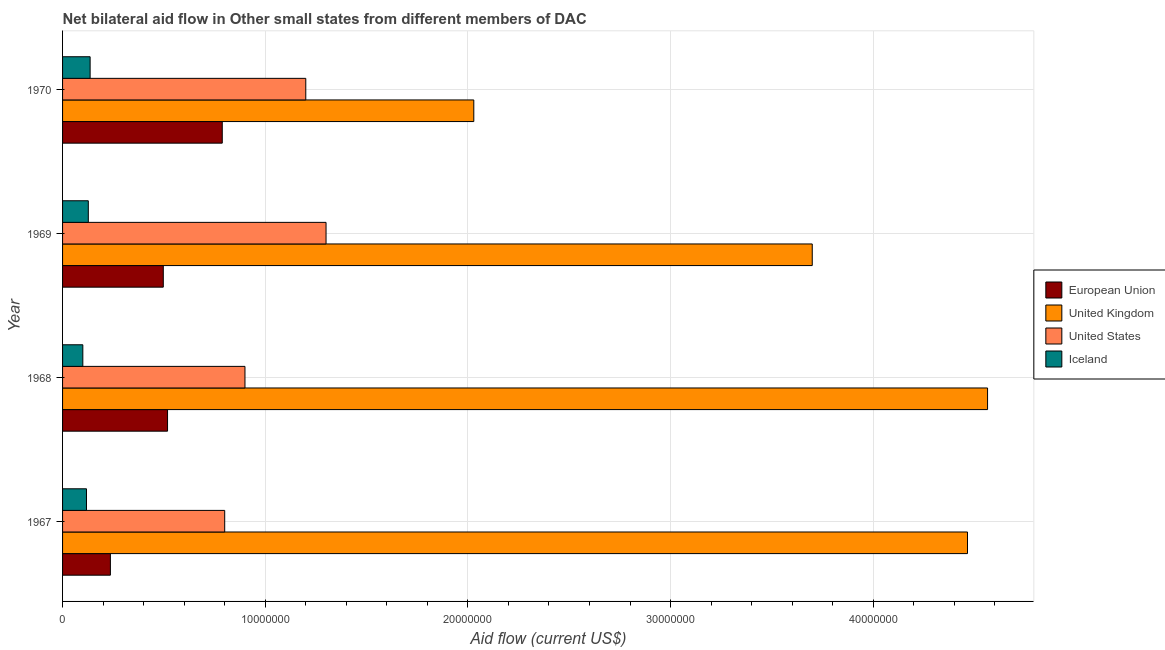Are the number of bars per tick equal to the number of legend labels?
Keep it short and to the point. Yes. How many bars are there on the 1st tick from the top?
Your response must be concise. 4. How many bars are there on the 1st tick from the bottom?
Make the answer very short. 4. What is the label of the 1st group of bars from the top?
Keep it short and to the point. 1970. What is the amount of aid given by uk in 1967?
Make the answer very short. 4.46e+07. Across all years, what is the maximum amount of aid given by eu?
Make the answer very short. 7.88e+06. Across all years, what is the minimum amount of aid given by us?
Your answer should be very brief. 8.00e+06. In which year was the amount of aid given by uk maximum?
Make the answer very short. 1968. In which year was the amount of aid given by uk minimum?
Your response must be concise. 1970. What is the total amount of aid given by us in the graph?
Provide a short and direct response. 4.20e+07. What is the difference between the amount of aid given by us in 1967 and that in 1970?
Provide a succinct answer. -4.00e+06. What is the difference between the amount of aid given by us in 1970 and the amount of aid given by eu in 1967?
Keep it short and to the point. 9.64e+06. What is the average amount of aid given by iceland per year?
Offer a very short reply. 1.20e+06. In the year 1970, what is the difference between the amount of aid given by us and amount of aid given by eu?
Make the answer very short. 4.12e+06. What is the ratio of the amount of aid given by eu in 1968 to that in 1970?
Ensure brevity in your answer.  0.66. Is the difference between the amount of aid given by eu in 1968 and 1969 greater than the difference between the amount of aid given by uk in 1968 and 1969?
Offer a very short reply. No. What is the difference between the highest and the lowest amount of aid given by eu?
Give a very brief answer. 5.52e+06. Is it the case that in every year, the sum of the amount of aid given by iceland and amount of aid given by us is greater than the sum of amount of aid given by eu and amount of aid given by uk?
Provide a short and direct response. No. What does the 3rd bar from the top in 1967 represents?
Make the answer very short. United Kingdom. What does the 2nd bar from the bottom in 1970 represents?
Provide a succinct answer. United Kingdom. Is it the case that in every year, the sum of the amount of aid given by eu and amount of aid given by uk is greater than the amount of aid given by us?
Your answer should be very brief. Yes. Does the graph contain grids?
Keep it short and to the point. Yes. How many legend labels are there?
Keep it short and to the point. 4. How are the legend labels stacked?
Make the answer very short. Vertical. What is the title of the graph?
Your response must be concise. Net bilateral aid flow in Other small states from different members of DAC. Does "HFC gas" appear as one of the legend labels in the graph?
Provide a succinct answer. No. What is the label or title of the X-axis?
Make the answer very short. Aid flow (current US$). What is the label or title of the Y-axis?
Make the answer very short. Year. What is the Aid flow (current US$) of European Union in 1967?
Make the answer very short. 2.36e+06. What is the Aid flow (current US$) in United Kingdom in 1967?
Give a very brief answer. 4.46e+07. What is the Aid flow (current US$) in Iceland in 1967?
Your answer should be compact. 1.18e+06. What is the Aid flow (current US$) in European Union in 1968?
Provide a succinct answer. 5.18e+06. What is the Aid flow (current US$) in United Kingdom in 1968?
Ensure brevity in your answer.  4.56e+07. What is the Aid flow (current US$) of United States in 1968?
Give a very brief answer. 9.00e+06. What is the Aid flow (current US$) in European Union in 1969?
Your answer should be compact. 4.97e+06. What is the Aid flow (current US$) in United Kingdom in 1969?
Keep it short and to the point. 3.70e+07. What is the Aid flow (current US$) of United States in 1969?
Give a very brief answer. 1.30e+07. What is the Aid flow (current US$) of Iceland in 1969?
Make the answer very short. 1.27e+06. What is the Aid flow (current US$) in European Union in 1970?
Your answer should be compact. 7.88e+06. What is the Aid flow (current US$) of United Kingdom in 1970?
Provide a succinct answer. 2.03e+07. What is the Aid flow (current US$) of Iceland in 1970?
Your answer should be compact. 1.36e+06. Across all years, what is the maximum Aid flow (current US$) in European Union?
Ensure brevity in your answer.  7.88e+06. Across all years, what is the maximum Aid flow (current US$) in United Kingdom?
Your response must be concise. 4.56e+07. Across all years, what is the maximum Aid flow (current US$) in United States?
Your response must be concise. 1.30e+07. Across all years, what is the maximum Aid flow (current US$) in Iceland?
Offer a very short reply. 1.36e+06. Across all years, what is the minimum Aid flow (current US$) of European Union?
Offer a terse response. 2.36e+06. Across all years, what is the minimum Aid flow (current US$) in United Kingdom?
Your answer should be compact. 2.03e+07. Across all years, what is the minimum Aid flow (current US$) of United States?
Keep it short and to the point. 8.00e+06. What is the total Aid flow (current US$) of European Union in the graph?
Provide a succinct answer. 2.04e+07. What is the total Aid flow (current US$) of United Kingdom in the graph?
Offer a terse response. 1.48e+08. What is the total Aid flow (current US$) of United States in the graph?
Keep it short and to the point. 4.20e+07. What is the total Aid flow (current US$) of Iceland in the graph?
Your response must be concise. 4.81e+06. What is the difference between the Aid flow (current US$) of European Union in 1967 and that in 1968?
Your response must be concise. -2.82e+06. What is the difference between the Aid flow (current US$) in United Kingdom in 1967 and that in 1968?
Make the answer very short. -9.90e+05. What is the difference between the Aid flow (current US$) of United States in 1967 and that in 1968?
Give a very brief answer. -1.00e+06. What is the difference between the Aid flow (current US$) in European Union in 1967 and that in 1969?
Ensure brevity in your answer.  -2.61e+06. What is the difference between the Aid flow (current US$) in United Kingdom in 1967 and that in 1969?
Provide a succinct answer. 7.66e+06. What is the difference between the Aid flow (current US$) of United States in 1967 and that in 1969?
Your response must be concise. -5.00e+06. What is the difference between the Aid flow (current US$) in Iceland in 1967 and that in 1969?
Provide a succinct answer. -9.00e+04. What is the difference between the Aid flow (current US$) in European Union in 1967 and that in 1970?
Make the answer very short. -5.52e+06. What is the difference between the Aid flow (current US$) of United Kingdom in 1967 and that in 1970?
Offer a very short reply. 2.44e+07. What is the difference between the Aid flow (current US$) in European Union in 1968 and that in 1969?
Offer a very short reply. 2.10e+05. What is the difference between the Aid flow (current US$) in United Kingdom in 1968 and that in 1969?
Provide a short and direct response. 8.65e+06. What is the difference between the Aid flow (current US$) in United States in 1968 and that in 1969?
Keep it short and to the point. -4.00e+06. What is the difference between the Aid flow (current US$) of Iceland in 1968 and that in 1969?
Provide a succinct answer. -2.70e+05. What is the difference between the Aid flow (current US$) of European Union in 1968 and that in 1970?
Offer a terse response. -2.70e+06. What is the difference between the Aid flow (current US$) of United Kingdom in 1968 and that in 1970?
Provide a short and direct response. 2.54e+07. What is the difference between the Aid flow (current US$) of United States in 1968 and that in 1970?
Your answer should be very brief. -3.00e+06. What is the difference between the Aid flow (current US$) of Iceland in 1968 and that in 1970?
Keep it short and to the point. -3.60e+05. What is the difference between the Aid flow (current US$) in European Union in 1969 and that in 1970?
Offer a very short reply. -2.91e+06. What is the difference between the Aid flow (current US$) of United Kingdom in 1969 and that in 1970?
Offer a terse response. 1.67e+07. What is the difference between the Aid flow (current US$) in Iceland in 1969 and that in 1970?
Offer a terse response. -9.00e+04. What is the difference between the Aid flow (current US$) of European Union in 1967 and the Aid flow (current US$) of United Kingdom in 1968?
Ensure brevity in your answer.  -4.33e+07. What is the difference between the Aid flow (current US$) in European Union in 1967 and the Aid flow (current US$) in United States in 1968?
Ensure brevity in your answer.  -6.64e+06. What is the difference between the Aid flow (current US$) in European Union in 1967 and the Aid flow (current US$) in Iceland in 1968?
Offer a terse response. 1.36e+06. What is the difference between the Aid flow (current US$) in United Kingdom in 1967 and the Aid flow (current US$) in United States in 1968?
Offer a very short reply. 3.56e+07. What is the difference between the Aid flow (current US$) of United Kingdom in 1967 and the Aid flow (current US$) of Iceland in 1968?
Keep it short and to the point. 4.36e+07. What is the difference between the Aid flow (current US$) in European Union in 1967 and the Aid flow (current US$) in United Kingdom in 1969?
Your answer should be very brief. -3.46e+07. What is the difference between the Aid flow (current US$) in European Union in 1967 and the Aid flow (current US$) in United States in 1969?
Offer a very short reply. -1.06e+07. What is the difference between the Aid flow (current US$) in European Union in 1967 and the Aid flow (current US$) in Iceland in 1969?
Make the answer very short. 1.09e+06. What is the difference between the Aid flow (current US$) of United Kingdom in 1967 and the Aid flow (current US$) of United States in 1969?
Provide a short and direct response. 3.16e+07. What is the difference between the Aid flow (current US$) in United Kingdom in 1967 and the Aid flow (current US$) in Iceland in 1969?
Make the answer very short. 4.34e+07. What is the difference between the Aid flow (current US$) of United States in 1967 and the Aid flow (current US$) of Iceland in 1969?
Make the answer very short. 6.73e+06. What is the difference between the Aid flow (current US$) of European Union in 1967 and the Aid flow (current US$) of United Kingdom in 1970?
Your response must be concise. -1.79e+07. What is the difference between the Aid flow (current US$) in European Union in 1967 and the Aid flow (current US$) in United States in 1970?
Provide a short and direct response. -9.64e+06. What is the difference between the Aid flow (current US$) of United Kingdom in 1967 and the Aid flow (current US$) of United States in 1970?
Your answer should be very brief. 3.26e+07. What is the difference between the Aid flow (current US$) of United Kingdom in 1967 and the Aid flow (current US$) of Iceland in 1970?
Provide a short and direct response. 4.33e+07. What is the difference between the Aid flow (current US$) of United States in 1967 and the Aid flow (current US$) of Iceland in 1970?
Keep it short and to the point. 6.64e+06. What is the difference between the Aid flow (current US$) of European Union in 1968 and the Aid flow (current US$) of United Kingdom in 1969?
Provide a succinct answer. -3.18e+07. What is the difference between the Aid flow (current US$) in European Union in 1968 and the Aid flow (current US$) in United States in 1969?
Provide a short and direct response. -7.82e+06. What is the difference between the Aid flow (current US$) of European Union in 1968 and the Aid flow (current US$) of Iceland in 1969?
Make the answer very short. 3.91e+06. What is the difference between the Aid flow (current US$) in United Kingdom in 1968 and the Aid flow (current US$) in United States in 1969?
Give a very brief answer. 3.26e+07. What is the difference between the Aid flow (current US$) in United Kingdom in 1968 and the Aid flow (current US$) in Iceland in 1969?
Your answer should be very brief. 4.44e+07. What is the difference between the Aid flow (current US$) of United States in 1968 and the Aid flow (current US$) of Iceland in 1969?
Offer a terse response. 7.73e+06. What is the difference between the Aid flow (current US$) in European Union in 1968 and the Aid flow (current US$) in United Kingdom in 1970?
Your response must be concise. -1.51e+07. What is the difference between the Aid flow (current US$) of European Union in 1968 and the Aid flow (current US$) of United States in 1970?
Your answer should be very brief. -6.82e+06. What is the difference between the Aid flow (current US$) of European Union in 1968 and the Aid flow (current US$) of Iceland in 1970?
Offer a very short reply. 3.82e+06. What is the difference between the Aid flow (current US$) of United Kingdom in 1968 and the Aid flow (current US$) of United States in 1970?
Provide a succinct answer. 3.36e+07. What is the difference between the Aid flow (current US$) of United Kingdom in 1968 and the Aid flow (current US$) of Iceland in 1970?
Your response must be concise. 4.43e+07. What is the difference between the Aid flow (current US$) of United States in 1968 and the Aid flow (current US$) of Iceland in 1970?
Make the answer very short. 7.64e+06. What is the difference between the Aid flow (current US$) in European Union in 1969 and the Aid flow (current US$) in United Kingdom in 1970?
Ensure brevity in your answer.  -1.53e+07. What is the difference between the Aid flow (current US$) of European Union in 1969 and the Aid flow (current US$) of United States in 1970?
Provide a succinct answer. -7.03e+06. What is the difference between the Aid flow (current US$) in European Union in 1969 and the Aid flow (current US$) in Iceland in 1970?
Ensure brevity in your answer.  3.61e+06. What is the difference between the Aid flow (current US$) in United Kingdom in 1969 and the Aid flow (current US$) in United States in 1970?
Offer a terse response. 2.50e+07. What is the difference between the Aid flow (current US$) of United Kingdom in 1969 and the Aid flow (current US$) of Iceland in 1970?
Your answer should be very brief. 3.56e+07. What is the difference between the Aid flow (current US$) in United States in 1969 and the Aid flow (current US$) in Iceland in 1970?
Your response must be concise. 1.16e+07. What is the average Aid flow (current US$) of European Union per year?
Keep it short and to the point. 5.10e+06. What is the average Aid flow (current US$) of United Kingdom per year?
Your answer should be compact. 3.69e+07. What is the average Aid flow (current US$) in United States per year?
Your answer should be compact. 1.05e+07. What is the average Aid flow (current US$) of Iceland per year?
Your answer should be very brief. 1.20e+06. In the year 1967, what is the difference between the Aid flow (current US$) of European Union and Aid flow (current US$) of United Kingdom?
Your answer should be very brief. -4.23e+07. In the year 1967, what is the difference between the Aid flow (current US$) of European Union and Aid flow (current US$) of United States?
Your response must be concise. -5.64e+06. In the year 1967, what is the difference between the Aid flow (current US$) in European Union and Aid flow (current US$) in Iceland?
Ensure brevity in your answer.  1.18e+06. In the year 1967, what is the difference between the Aid flow (current US$) of United Kingdom and Aid flow (current US$) of United States?
Your answer should be compact. 3.66e+07. In the year 1967, what is the difference between the Aid flow (current US$) in United Kingdom and Aid flow (current US$) in Iceland?
Provide a succinct answer. 4.35e+07. In the year 1967, what is the difference between the Aid flow (current US$) in United States and Aid flow (current US$) in Iceland?
Provide a succinct answer. 6.82e+06. In the year 1968, what is the difference between the Aid flow (current US$) in European Union and Aid flow (current US$) in United Kingdom?
Your response must be concise. -4.05e+07. In the year 1968, what is the difference between the Aid flow (current US$) in European Union and Aid flow (current US$) in United States?
Give a very brief answer. -3.82e+06. In the year 1968, what is the difference between the Aid flow (current US$) of European Union and Aid flow (current US$) of Iceland?
Ensure brevity in your answer.  4.18e+06. In the year 1968, what is the difference between the Aid flow (current US$) of United Kingdom and Aid flow (current US$) of United States?
Provide a short and direct response. 3.66e+07. In the year 1968, what is the difference between the Aid flow (current US$) of United Kingdom and Aid flow (current US$) of Iceland?
Ensure brevity in your answer.  4.46e+07. In the year 1968, what is the difference between the Aid flow (current US$) in United States and Aid flow (current US$) in Iceland?
Your response must be concise. 8.00e+06. In the year 1969, what is the difference between the Aid flow (current US$) of European Union and Aid flow (current US$) of United Kingdom?
Keep it short and to the point. -3.20e+07. In the year 1969, what is the difference between the Aid flow (current US$) of European Union and Aid flow (current US$) of United States?
Offer a terse response. -8.03e+06. In the year 1969, what is the difference between the Aid flow (current US$) of European Union and Aid flow (current US$) of Iceland?
Your answer should be very brief. 3.70e+06. In the year 1969, what is the difference between the Aid flow (current US$) of United Kingdom and Aid flow (current US$) of United States?
Ensure brevity in your answer.  2.40e+07. In the year 1969, what is the difference between the Aid flow (current US$) in United Kingdom and Aid flow (current US$) in Iceland?
Offer a terse response. 3.57e+07. In the year 1969, what is the difference between the Aid flow (current US$) of United States and Aid flow (current US$) of Iceland?
Give a very brief answer. 1.17e+07. In the year 1970, what is the difference between the Aid flow (current US$) in European Union and Aid flow (current US$) in United Kingdom?
Your response must be concise. -1.24e+07. In the year 1970, what is the difference between the Aid flow (current US$) of European Union and Aid flow (current US$) of United States?
Make the answer very short. -4.12e+06. In the year 1970, what is the difference between the Aid flow (current US$) of European Union and Aid flow (current US$) of Iceland?
Your answer should be very brief. 6.52e+06. In the year 1970, what is the difference between the Aid flow (current US$) in United Kingdom and Aid flow (current US$) in United States?
Your answer should be compact. 8.29e+06. In the year 1970, what is the difference between the Aid flow (current US$) of United Kingdom and Aid flow (current US$) of Iceland?
Your answer should be very brief. 1.89e+07. In the year 1970, what is the difference between the Aid flow (current US$) of United States and Aid flow (current US$) of Iceland?
Give a very brief answer. 1.06e+07. What is the ratio of the Aid flow (current US$) of European Union in 1967 to that in 1968?
Ensure brevity in your answer.  0.46. What is the ratio of the Aid flow (current US$) in United Kingdom in 1967 to that in 1968?
Give a very brief answer. 0.98. What is the ratio of the Aid flow (current US$) of Iceland in 1967 to that in 1968?
Keep it short and to the point. 1.18. What is the ratio of the Aid flow (current US$) of European Union in 1967 to that in 1969?
Offer a terse response. 0.47. What is the ratio of the Aid flow (current US$) in United Kingdom in 1967 to that in 1969?
Keep it short and to the point. 1.21. What is the ratio of the Aid flow (current US$) in United States in 1967 to that in 1969?
Keep it short and to the point. 0.62. What is the ratio of the Aid flow (current US$) in Iceland in 1967 to that in 1969?
Provide a succinct answer. 0.93. What is the ratio of the Aid flow (current US$) in European Union in 1967 to that in 1970?
Your answer should be very brief. 0.3. What is the ratio of the Aid flow (current US$) of United Kingdom in 1967 to that in 1970?
Your answer should be very brief. 2.2. What is the ratio of the Aid flow (current US$) in United States in 1967 to that in 1970?
Provide a succinct answer. 0.67. What is the ratio of the Aid flow (current US$) in Iceland in 1967 to that in 1970?
Offer a terse response. 0.87. What is the ratio of the Aid flow (current US$) in European Union in 1968 to that in 1969?
Your answer should be very brief. 1.04. What is the ratio of the Aid flow (current US$) of United Kingdom in 1968 to that in 1969?
Offer a terse response. 1.23. What is the ratio of the Aid flow (current US$) of United States in 1968 to that in 1969?
Offer a terse response. 0.69. What is the ratio of the Aid flow (current US$) in Iceland in 1968 to that in 1969?
Your answer should be compact. 0.79. What is the ratio of the Aid flow (current US$) in European Union in 1968 to that in 1970?
Your answer should be very brief. 0.66. What is the ratio of the Aid flow (current US$) of United Kingdom in 1968 to that in 1970?
Keep it short and to the point. 2.25. What is the ratio of the Aid flow (current US$) in Iceland in 1968 to that in 1970?
Make the answer very short. 0.74. What is the ratio of the Aid flow (current US$) of European Union in 1969 to that in 1970?
Make the answer very short. 0.63. What is the ratio of the Aid flow (current US$) in United Kingdom in 1969 to that in 1970?
Offer a terse response. 1.82. What is the ratio of the Aid flow (current US$) in Iceland in 1969 to that in 1970?
Keep it short and to the point. 0.93. What is the difference between the highest and the second highest Aid flow (current US$) of European Union?
Your response must be concise. 2.70e+06. What is the difference between the highest and the second highest Aid flow (current US$) in United Kingdom?
Offer a terse response. 9.90e+05. What is the difference between the highest and the second highest Aid flow (current US$) in United States?
Your answer should be compact. 1.00e+06. What is the difference between the highest and the lowest Aid flow (current US$) of European Union?
Your response must be concise. 5.52e+06. What is the difference between the highest and the lowest Aid flow (current US$) in United Kingdom?
Offer a very short reply. 2.54e+07. What is the difference between the highest and the lowest Aid flow (current US$) in United States?
Make the answer very short. 5.00e+06. What is the difference between the highest and the lowest Aid flow (current US$) in Iceland?
Offer a very short reply. 3.60e+05. 